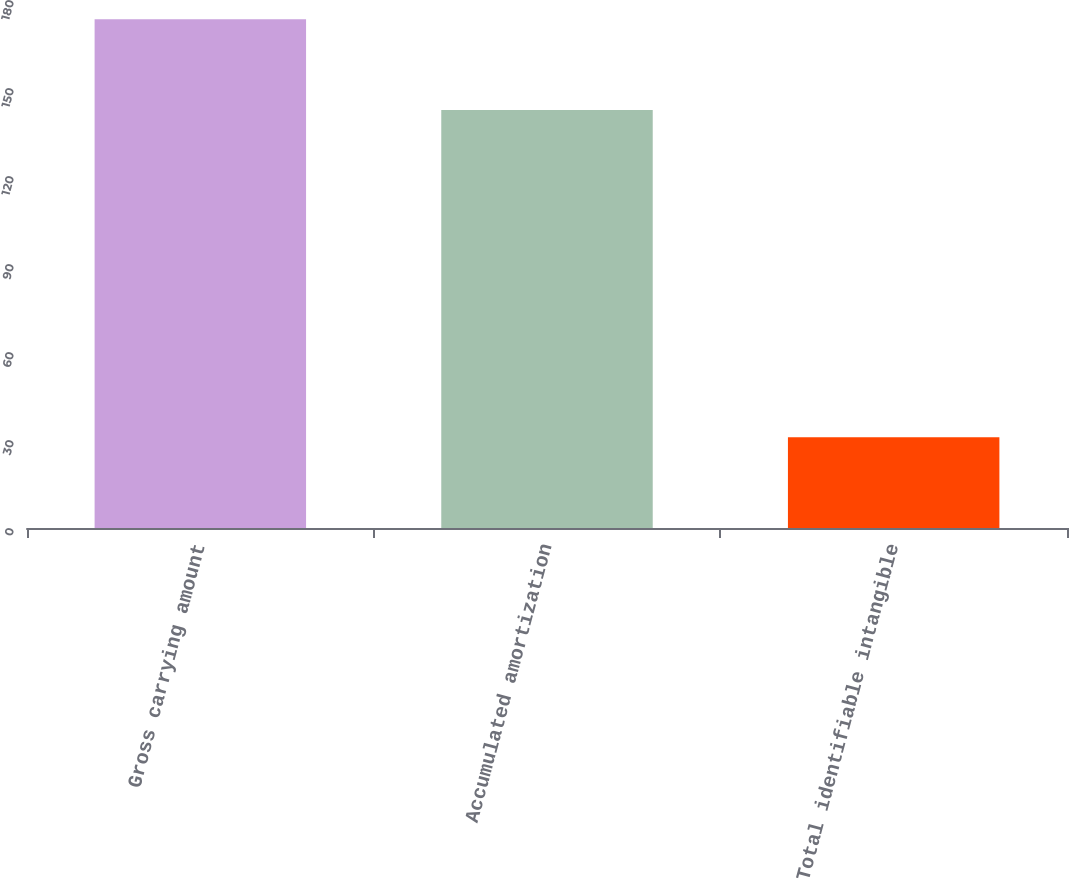<chart> <loc_0><loc_0><loc_500><loc_500><bar_chart><fcel>Gross carrying amount<fcel>Accumulated amortization<fcel>Total identifiable intangible<nl><fcel>173.4<fcel>142.5<fcel>30.9<nl></chart> 